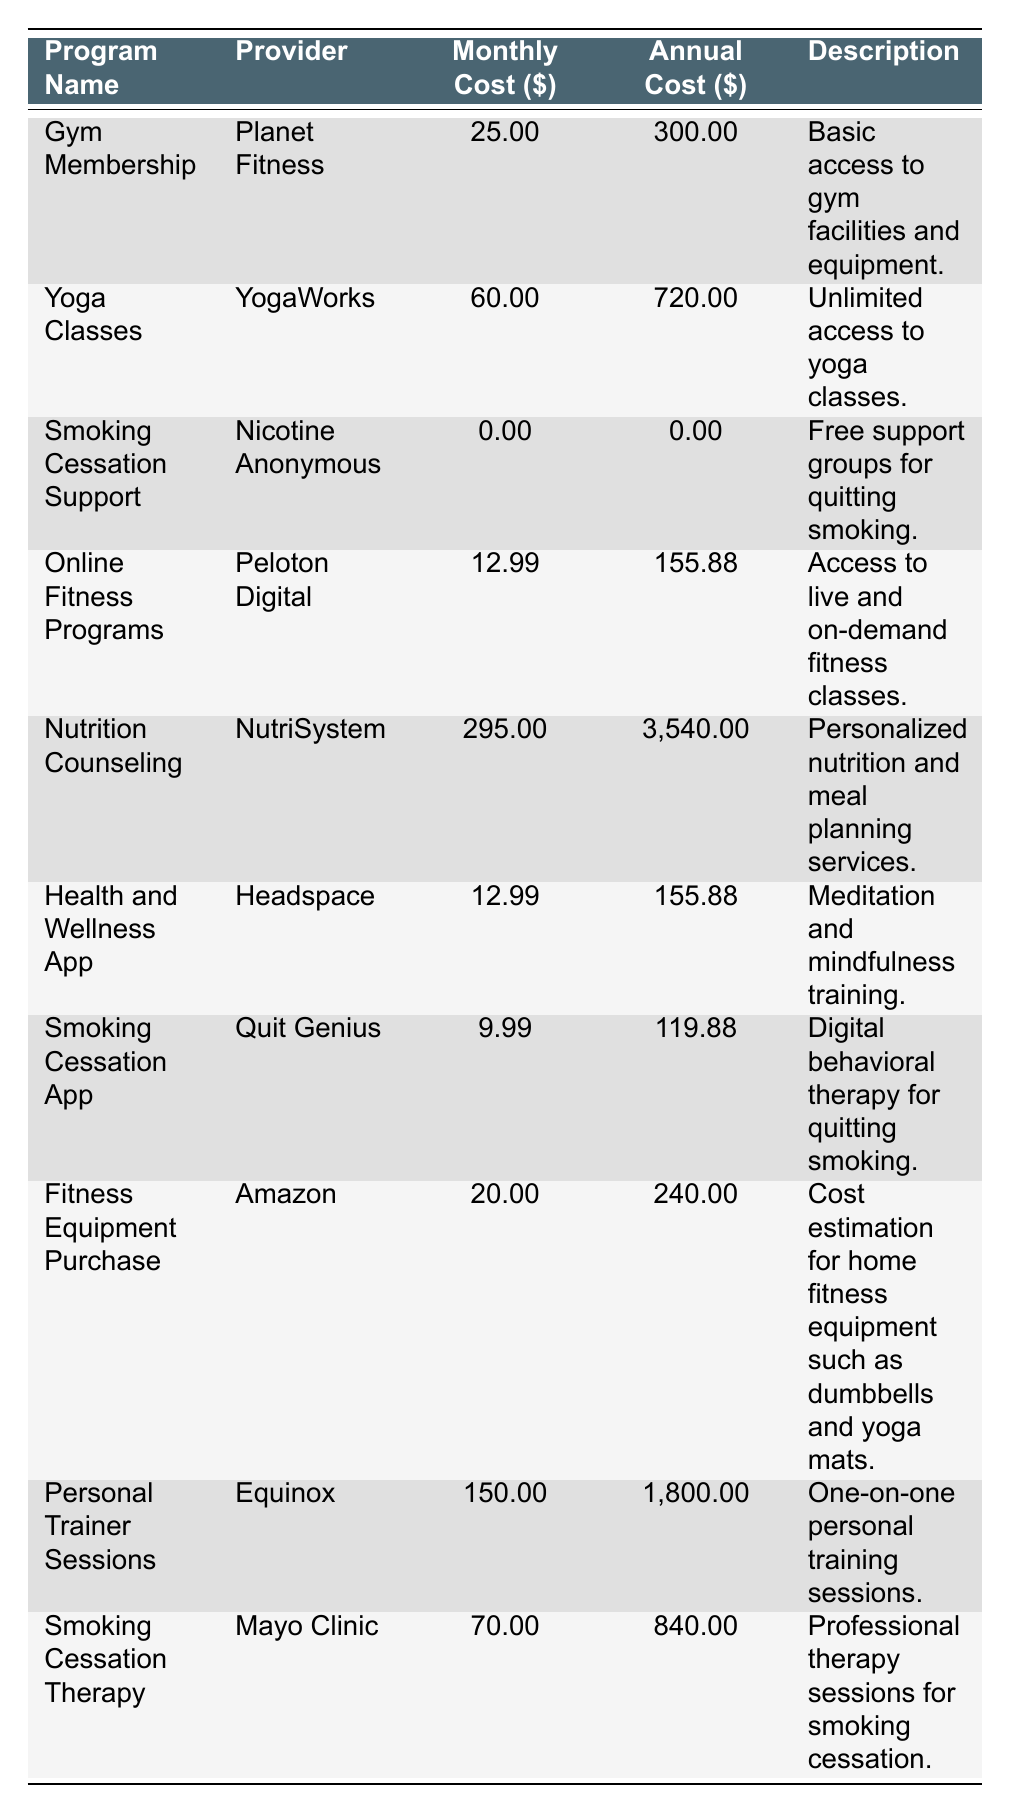What is the monthly cost of the Yoga Classes? The table lists the monthly cost for the Yoga Classes under the "Monthly Cost" column, which shows a value of 60.00.
Answer: 60.00 What is the annual cost of the Gym Membership? The annual cost for the Gym Membership is explicitly mentioned in the "Annual Cost" column, which indicates a value of 300.00.
Answer: 300.00 Is there a program that offers free smoking cessation support? The table shows that "Smoking Cessation Support" from Nicotine Anonymous has a monthly and annual cost of 0.00, indicating it is free.
Answer: Yes What is the total annual cost for Online Fitness Programs and Health and Wellness App combined? The annual cost for Online Fitness Programs is 155.88 and for Health and Wellness App is also 155.88. Adding these, we get 155.88 + 155.88 = 311.76.
Answer: 311.76 Which program provider has the highest monthly cost? Evaluate the monthly costs listed in the table. The highest monthly cost is for Nutrition Counseling from NutriSystem at 295.00.
Answer: NutriSystem What is the difference between the monthly costs of the Smoking Cessation Therapy and the Smoking Cessation App? The monthly cost of Smoking Cessation Therapy is 70.00, and for the Smoking Cessation App, it is 9.99. The difference is calculated as 70.00 - 9.99 = 60.01.
Answer: 60.01 Is the cost of a Personal Trainer Session more than double the cost of the Gym Membership? The cost for a Personal Trainer Session is 150.00, while the Gym Membership is 25.00. Double the Gym Membership is 50.00, and since 150.00 is greater than 50.00, the statement is true.
Answer: Yes What is the average monthly cost of the fitness programs listed? The total monthly cost can be calculated by adding all the monthly costs: (25 + 60 + 0 + 12.99 + 295 + 12.99 + 9.99 + 20 + 150 + 70) = 655.96. There are 10 programs, so the average is 655.96 / 10 = 65.596.
Answer: 65.60 Which program offers unlimited access to classes? The description for "Yoga Classes" from YogaWorks states "Unlimited access to yoga classes."
Answer: Yoga Classes 